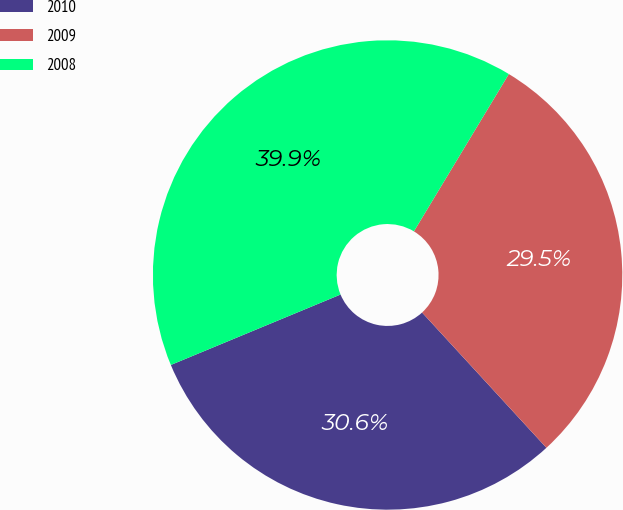Convert chart. <chart><loc_0><loc_0><loc_500><loc_500><pie_chart><fcel>2010<fcel>2009<fcel>2008<nl><fcel>30.57%<fcel>29.53%<fcel>39.9%<nl></chart> 